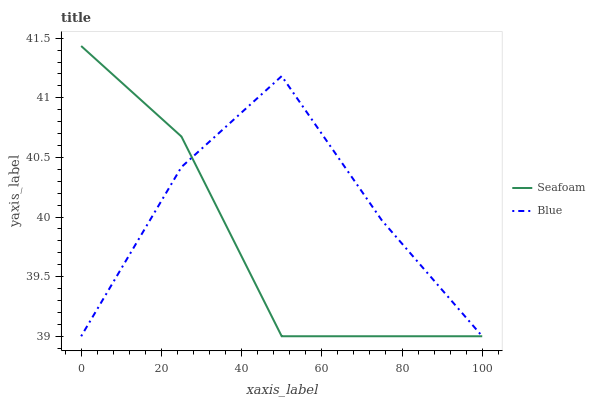Does Seafoam have the minimum area under the curve?
Answer yes or no. Yes. Does Blue have the maximum area under the curve?
Answer yes or no. Yes. Does Seafoam have the maximum area under the curve?
Answer yes or no. No. Is Seafoam the smoothest?
Answer yes or no. Yes. Is Blue the roughest?
Answer yes or no. Yes. Is Seafoam the roughest?
Answer yes or no. No. Does Blue have the lowest value?
Answer yes or no. Yes. Does Seafoam have the highest value?
Answer yes or no. Yes. Does Blue intersect Seafoam?
Answer yes or no. Yes. Is Blue less than Seafoam?
Answer yes or no. No. Is Blue greater than Seafoam?
Answer yes or no. No. 